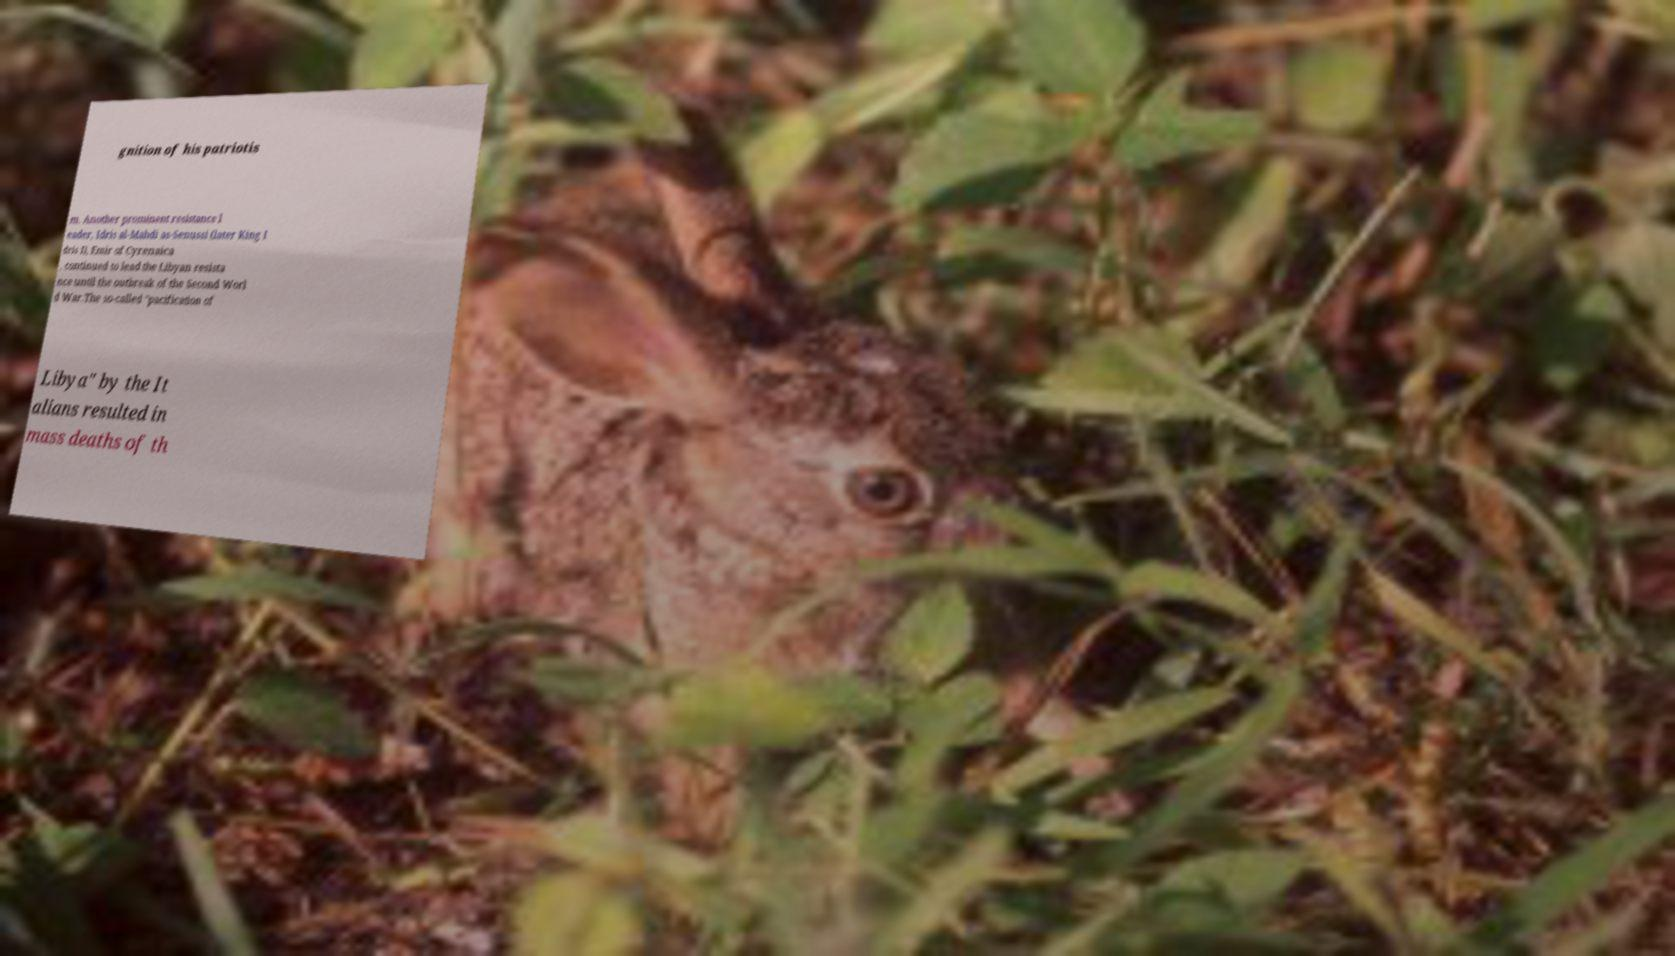What messages or text are displayed in this image? I need them in a readable, typed format. gnition of his patriotis m. Another prominent resistance l eader, Idris al-Mahdi as-Senussi (later King I dris I), Emir of Cyrenaica , continued to lead the Libyan resista nce until the outbreak of the Second Worl d War.The so-called "pacification of Libya" by the It alians resulted in mass deaths of th 